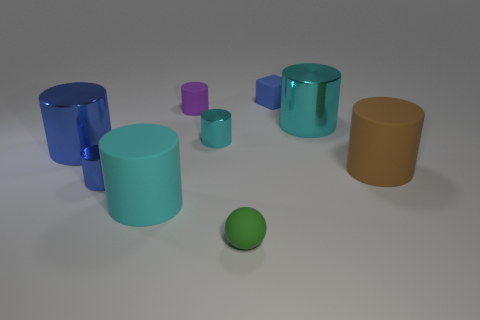How many other things are the same color as the tiny rubber sphere? Upon analyzing the image, I notice that none of the other items share the exact hue of the tiny green rubber sphere. Each object presents a unique shade and thus, I would conclude that there are zero items of the same color as the sphere. 